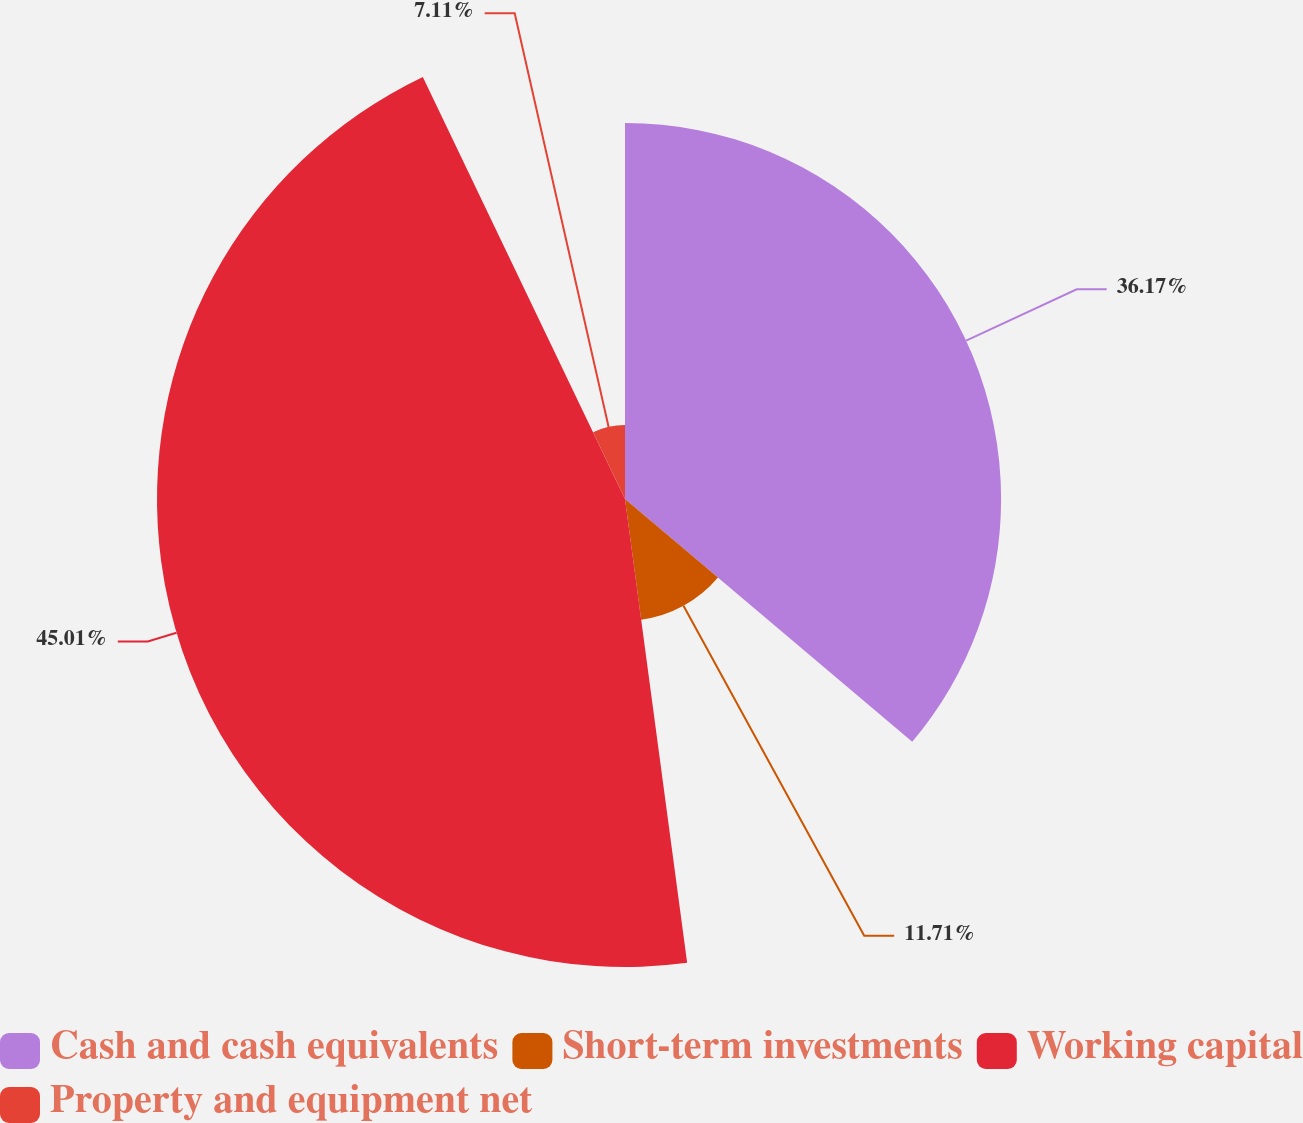Convert chart to OTSL. <chart><loc_0><loc_0><loc_500><loc_500><pie_chart><fcel>Cash and cash equivalents<fcel>Short-term investments<fcel>Working capital<fcel>Property and equipment net<nl><fcel>36.17%<fcel>11.71%<fcel>45.01%<fcel>7.11%<nl></chart> 